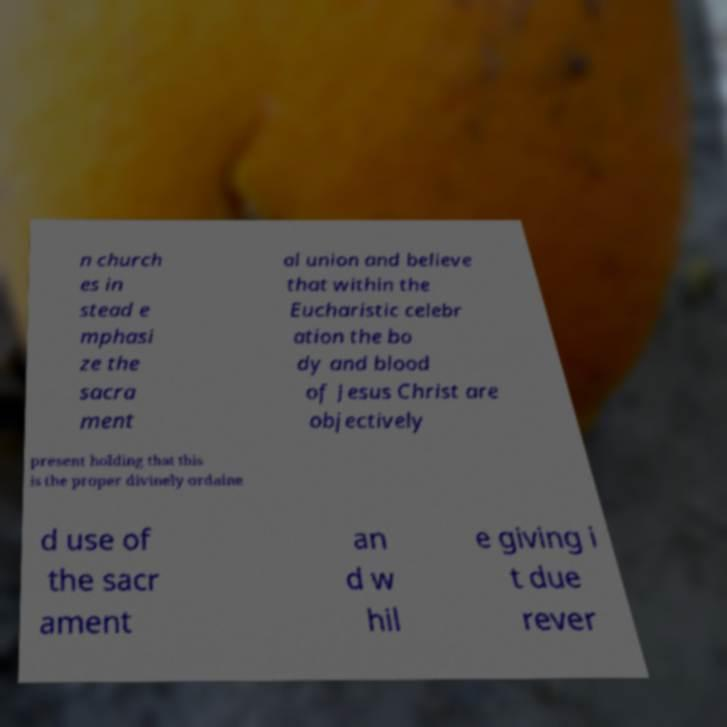Could you extract and type out the text from this image? n church es in stead e mphasi ze the sacra ment al union and believe that within the Eucharistic celebr ation the bo dy and blood of Jesus Christ are objectively present holding that this is the proper divinely ordaine d use of the sacr ament an d w hil e giving i t due rever 